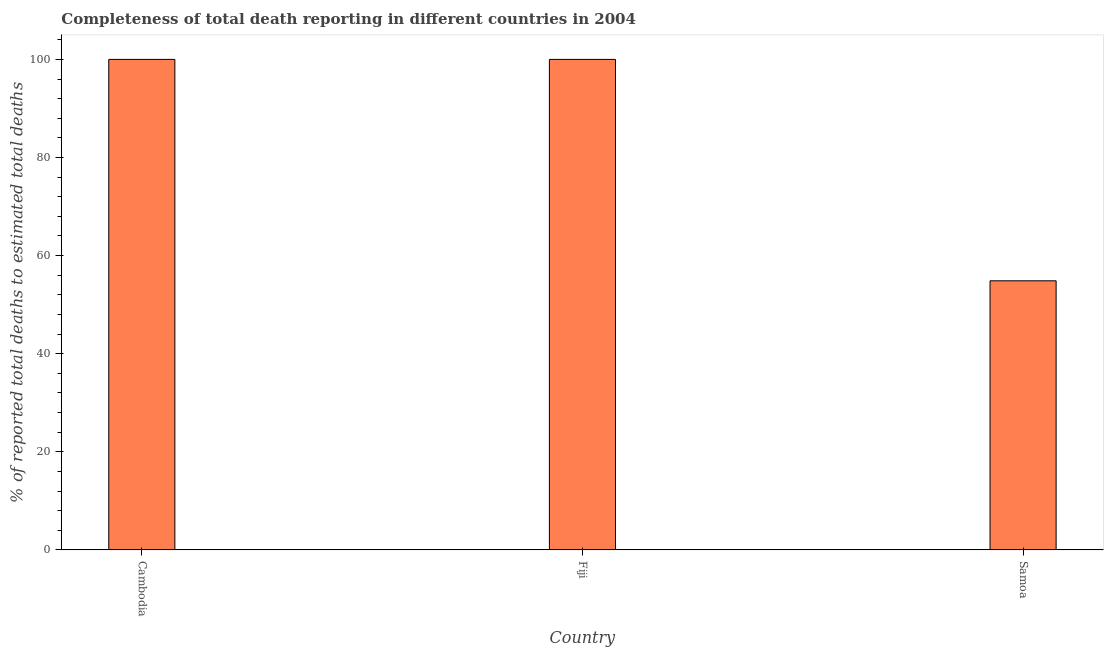What is the title of the graph?
Keep it short and to the point. Completeness of total death reporting in different countries in 2004. What is the label or title of the Y-axis?
Your response must be concise. % of reported total deaths to estimated total deaths. What is the completeness of total death reports in Cambodia?
Make the answer very short. 100. Across all countries, what is the minimum completeness of total death reports?
Provide a succinct answer. 54.86. In which country was the completeness of total death reports maximum?
Offer a very short reply. Cambodia. In which country was the completeness of total death reports minimum?
Keep it short and to the point. Samoa. What is the sum of the completeness of total death reports?
Keep it short and to the point. 254.86. What is the difference between the completeness of total death reports in Fiji and Samoa?
Make the answer very short. 45.13. What is the average completeness of total death reports per country?
Your answer should be compact. 84.95. What is the ratio of the completeness of total death reports in Fiji to that in Samoa?
Offer a very short reply. 1.82. Is the completeness of total death reports in Fiji less than that in Samoa?
Your answer should be compact. No. Is the difference between the completeness of total death reports in Cambodia and Fiji greater than the difference between any two countries?
Make the answer very short. No. What is the difference between the highest and the second highest completeness of total death reports?
Your answer should be very brief. 0. Is the sum of the completeness of total death reports in Cambodia and Fiji greater than the maximum completeness of total death reports across all countries?
Your response must be concise. Yes. What is the difference between the highest and the lowest completeness of total death reports?
Make the answer very short. 45.14. How many bars are there?
Your answer should be very brief. 3. Are all the bars in the graph horizontal?
Keep it short and to the point. No. How many countries are there in the graph?
Your response must be concise. 3. What is the % of reported total deaths to estimated total deaths in Samoa?
Make the answer very short. 54.86. What is the difference between the % of reported total deaths to estimated total deaths in Cambodia and Fiji?
Offer a very short reply. 0. What is the difference between the % of reported total deaths to estimated total deaths in Cambodia and Samoa?
Make the answer very short. 45.14. What is the difference between the % of reported total deaths to estimated total deaths in Fiji and Samoa?
Your answer should be compact. 45.14. What is the ratio of the % of reported total deaths to estimated total deaths in Cambodia to that in Samoa?
Offer a terse response. 1.82. What is the ratio of the % of reported total deaths to estimated total deaths in Fiji to that in Samoa?
Keep it short and to the point. 1.82. 